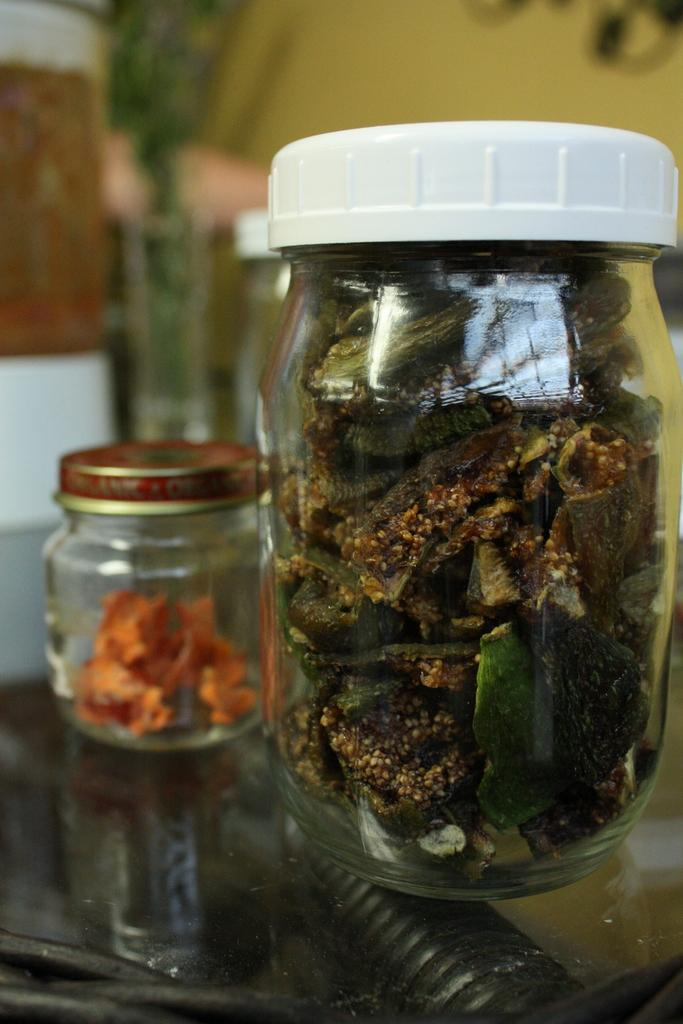What type of flowers can be seen on the desk in the office? There is no image or information provided about an office or flowers, so we cannot determine if there are any flowers in the office. 